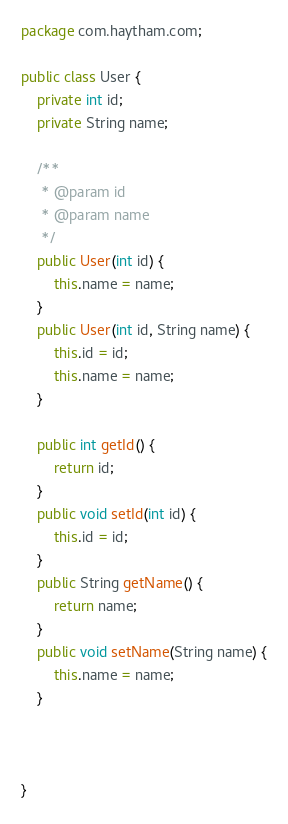Convert code to text. <code><loc_0><loc_0><loc_500><loc_500><_Java_>package com.haytham.com;

public class User {
	private int id;
	private String name;

	/**
	 * @param id
	 * @param name
	 */
	public User(int id) {
		this.name = name;
	}
	public User(int id, String name) {
		this.id = id;
		this.name = name;
	}

	public int getId() {
		return id;
	}
	public void setId(int id) {
		this.id = id;
	}
	public String getName() {
		return name;
	}
	public void setName(String name) {
		this.name = name;
	}
	
	

}
</code> 